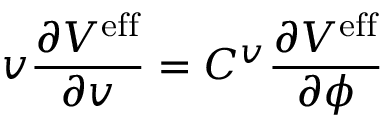<formula> <loc_0><loc_0><loc_500><loc_500>v \frac { \partial V ^ { e f f } } { \partial v } = C ^ { v } \frac { \partial V ^ { e f f } } { \partial \phi }</formula> 